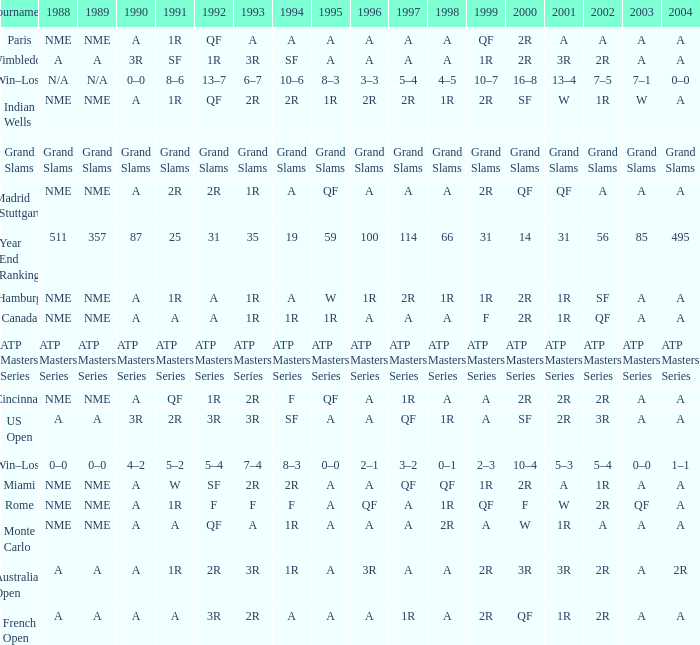What shows for 2002 when the 1991 is w? 1R. 